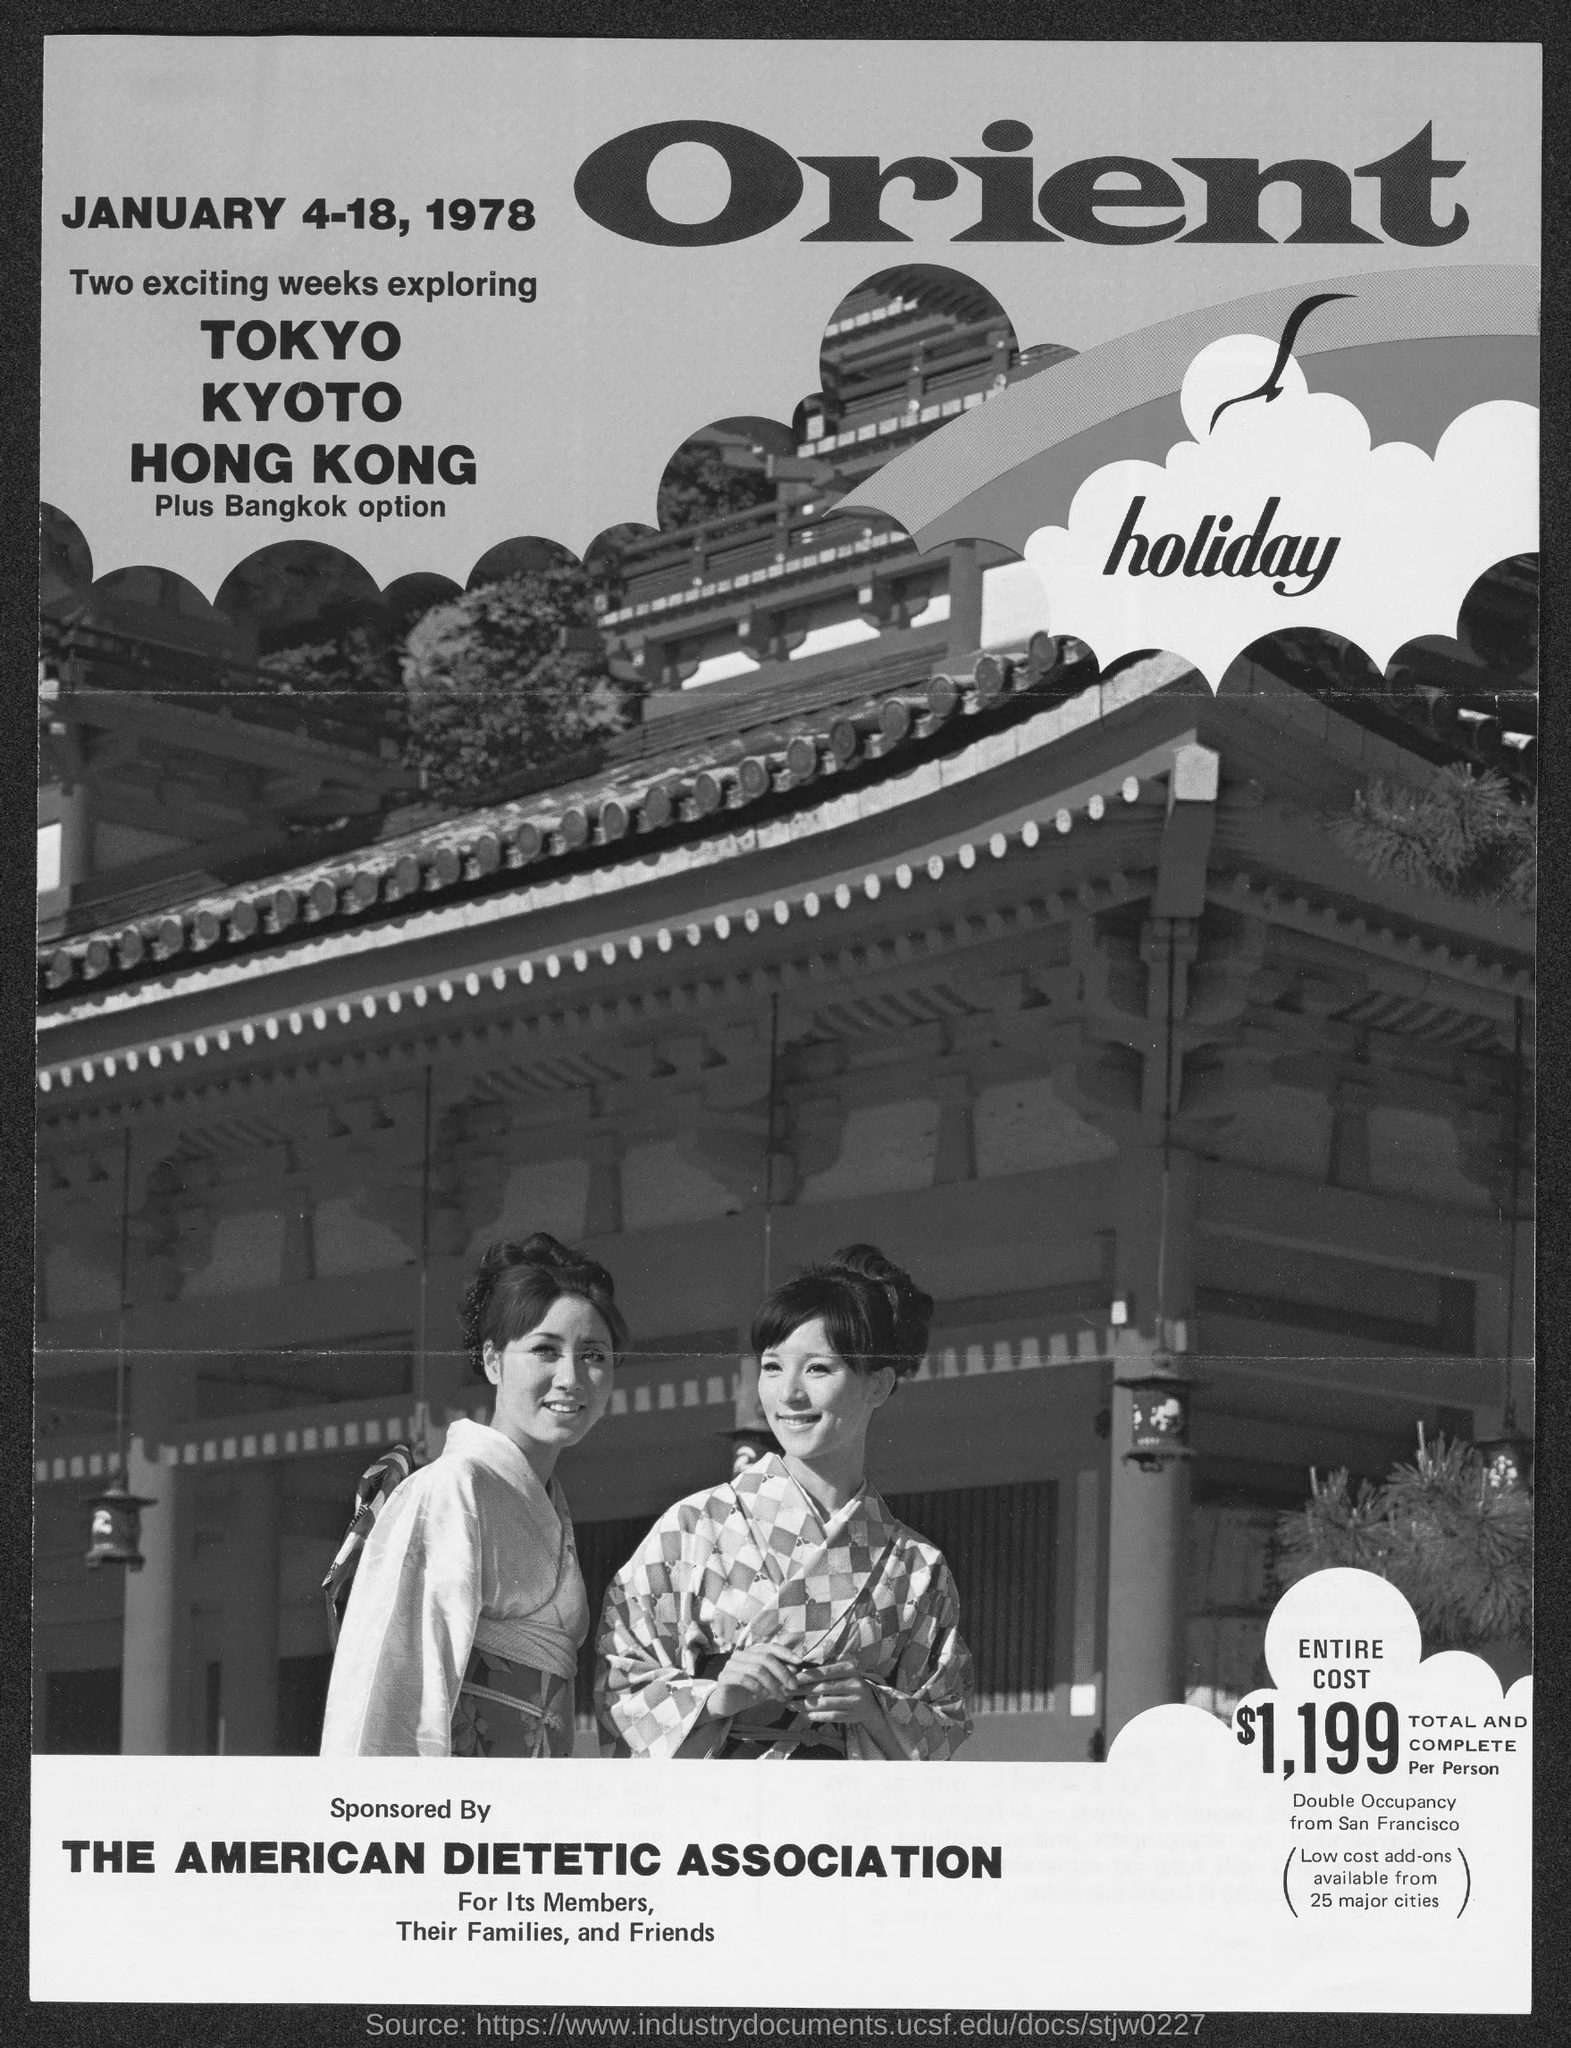Outline some significant characteristics in this image. The cost of the program is $1,199 per person, which is the total cost for the entire program. 